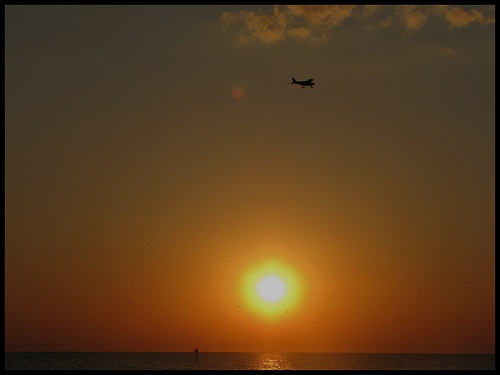Describe the objects in this image and their specific colors. I can see a airplane in black and maroon tones in this image. 